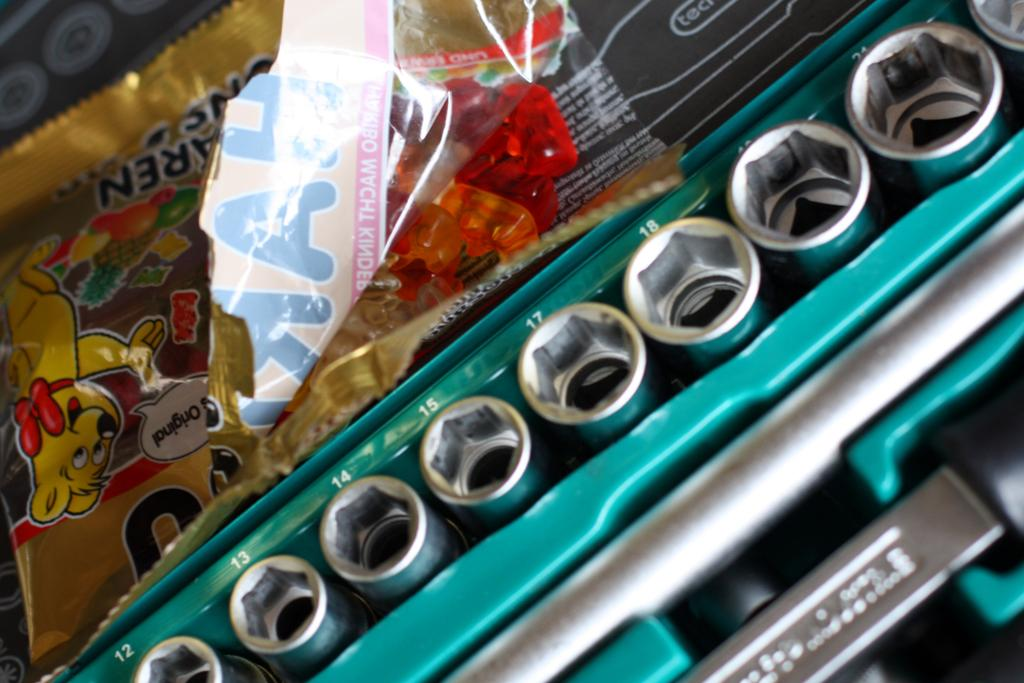What is the main object in the image? There is a jelly packet in the image. What other type of object can be seen in the image? There is an electronic gadget in the image. Can you describe any other items present in the image? There are various other things in the image. How many zebras are visible in the image? There are no zebras present in the image. What type of clothing are the women wearing in the image? There are no women present in the image. 